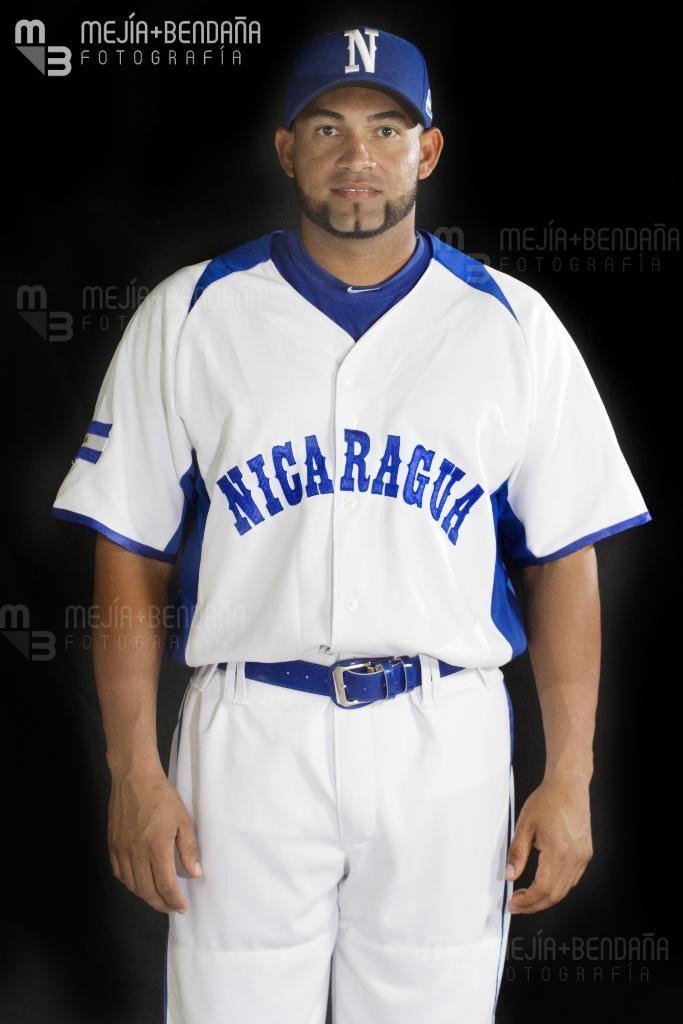Provide a one-sentence caption for the provided image. A baseball player for Nicaragua stands posing for a photo. 